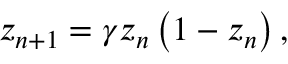Convert formula to latex. <formula><loc_0><loc_0><loc_500><loc_500>z _ { n + 1 } = \gamma z _ { n } \left ( 1 - z _ { n } \right ) ,</formula> 